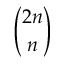Convert formula to latex. <formula><loc_0><loc_0><loc_500><loc_500>\binom { 2 n } { n }</formula> 